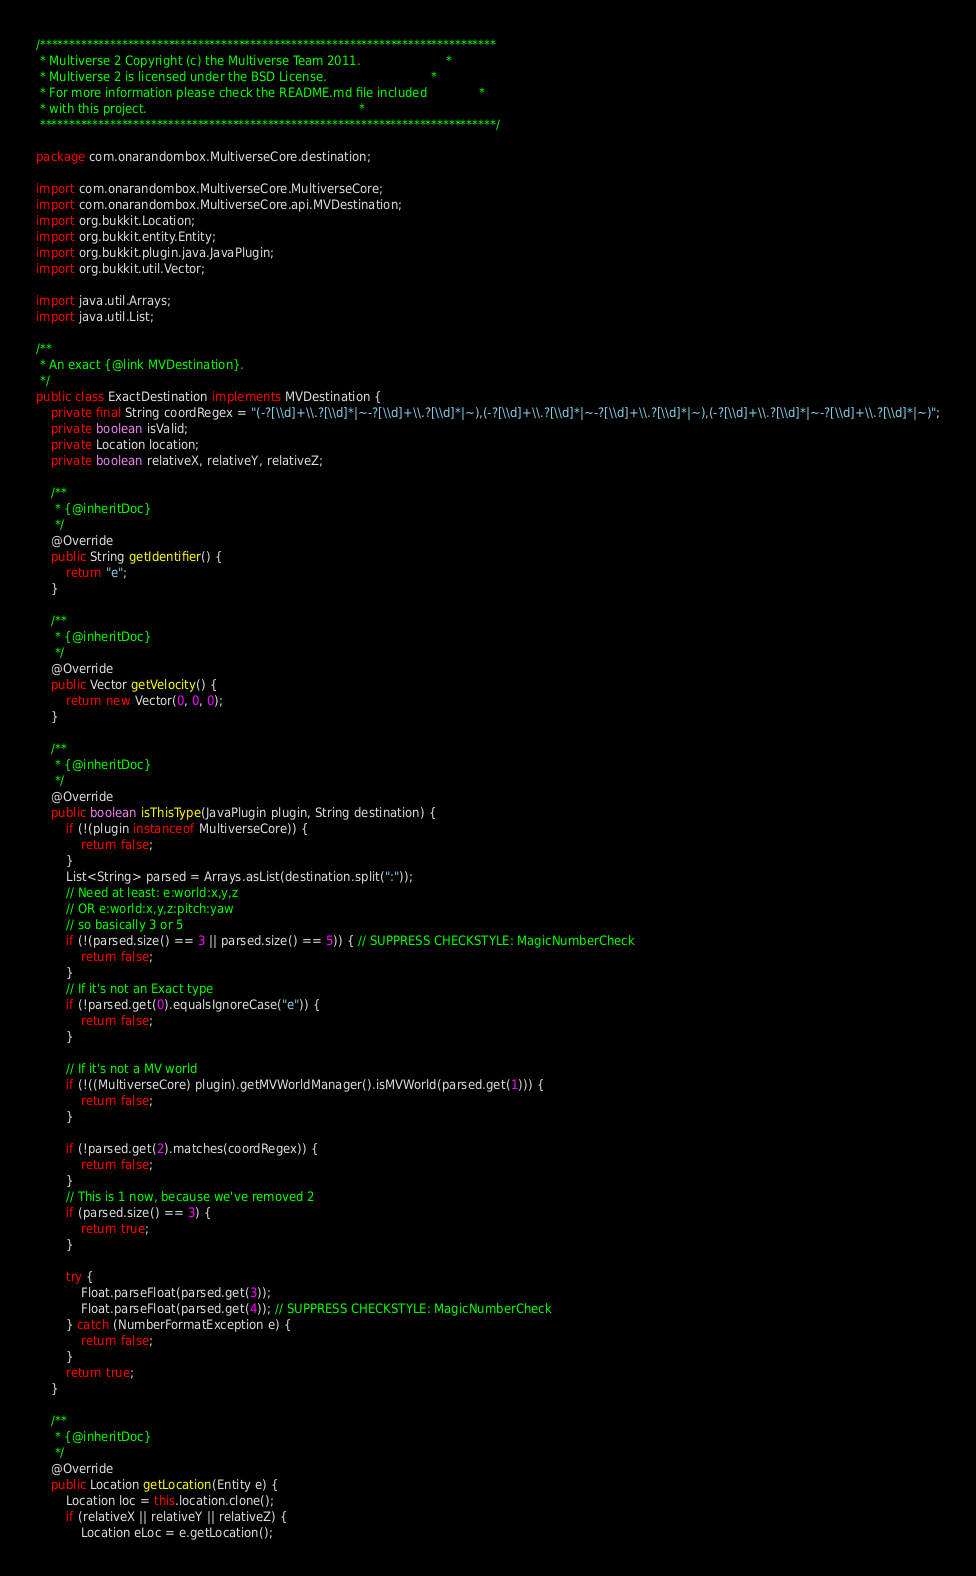<code> <loc_0><loc_0><loc_500><loc_500><_Java_>/******************************************************************************
 * Multiverse 2 Copyright (c) the Multiverse Team 2011.                       *
 * Multiverse 2 is licensed under the BSD License.                            *
 * For more information please check the README.md file included              *
 * with this project.                                                         *
 ******************************************************************************/

package com.onarandombox.MultiverseCore.destination;

import com.onarandombox.MultiverseCore.MultiverseCore;
import com.onarandombox.MultiverseCore.api.MVDestination;
import org.bukkit.Location;
import org.bukkit.entity.Entity;
import org.bukkit.plugin.java.JavaPlugin;
import org.bukkit.util.Vector;

import java.util.Arrays;
import java.util.List;

/**
 * An exact {@link MVDestination}.
 */
public class ExactDestination implements MVDestination {
    private final String coordRegex = "(-?[\\d]+\\.?[\\d]*|~-?[\\d]+\\.?[\\d]*|~),(-?[\\d]+\\.?[\\d]*|~-?[\\d]+\\.?[\\d]*|~),(-?[\\d]+\\.?[\\d]*|~-?[\\d]+\\.?[\\d]*|~)";
    private boolean isValid;
    private Location location;
    private boolean relativeX, relativeY, relativeZ;

    /**
     * {@inheritDoc}
     */
    @Override
    public String getIdentifier() {
        return "e";
    }

    /**
     * {@inheritDoc}
     */
    @Override
    public Vector getVelocity() {
        return new Vector(0, 0, 0);
    }

    /**
     * {@inheritDoc}
     */
    @Override
    public boolean isThisType(JavaPlugin plugin, String destination) {
        if (!(plugin instanceof MultiverseCore)) {
            return false;
        }
        List<String> parsed = Arrays.asList(destination.split(":"));
        // Need at least: e:world:x,y,z
        // OR e:world:x,y,z:pitch:yaw
        // so basically 3 or 5
        if (!(parsed.size() == 3 || parsed.size() == 5)) { // SUPPRESS CHECKSTYLE: MagicNumberCheck
            return false;
        }
        // If it's not an Exact type
        if (!parsed.get(0).equalsIgnoreCase("e")) {
            return false;
        }

        // If it's not a MV world
        if (!((MultiverseCore) plugin).getMVWorldManager().isMVWorld(parsed.get(1))) {
            return false;
        }

        if (!parsed.get(2).matches(coordRegex)) {
            return false;
        }
        // This is 1 now, because we've removed 2
        if (parsed.size() == 3) {
            return true;
        }

        try {
            Float.parseFloat(parsed.get(3));
            Float.parseFloat(parsed.get(4)); // SUPPRESS CHECKSTYLE: MagicNumberCheck
        } catch (NumberFormatException e) {
            return false;
        }
        return true;
    }

    /**
     * {@inheritDoc}
     */
    @Override
    public Location getLocation(Entity e) {
        Location loc = this.location.clone();
        if (relativeX || relativeY || relativeZ) {
            Location eLoc = e.getLocation();</code> 